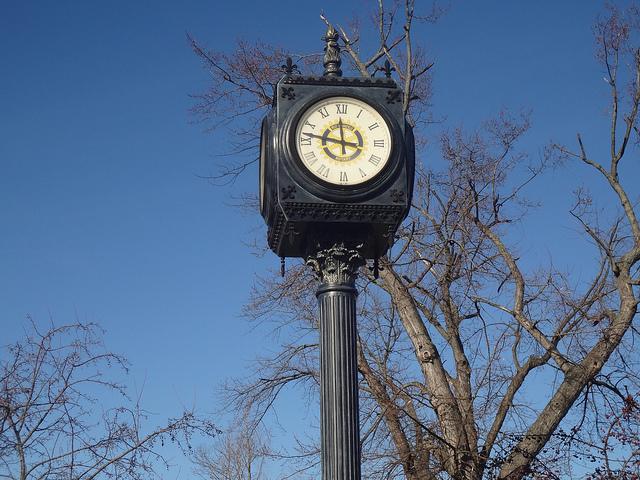What season is it?
Answer briefly. Winter. What is the shape of the clock?
Quick response, please. Circle. What time is it?
Concise answer only. 11:47. What time does the clock say?
Answer briefly. 11:46. 